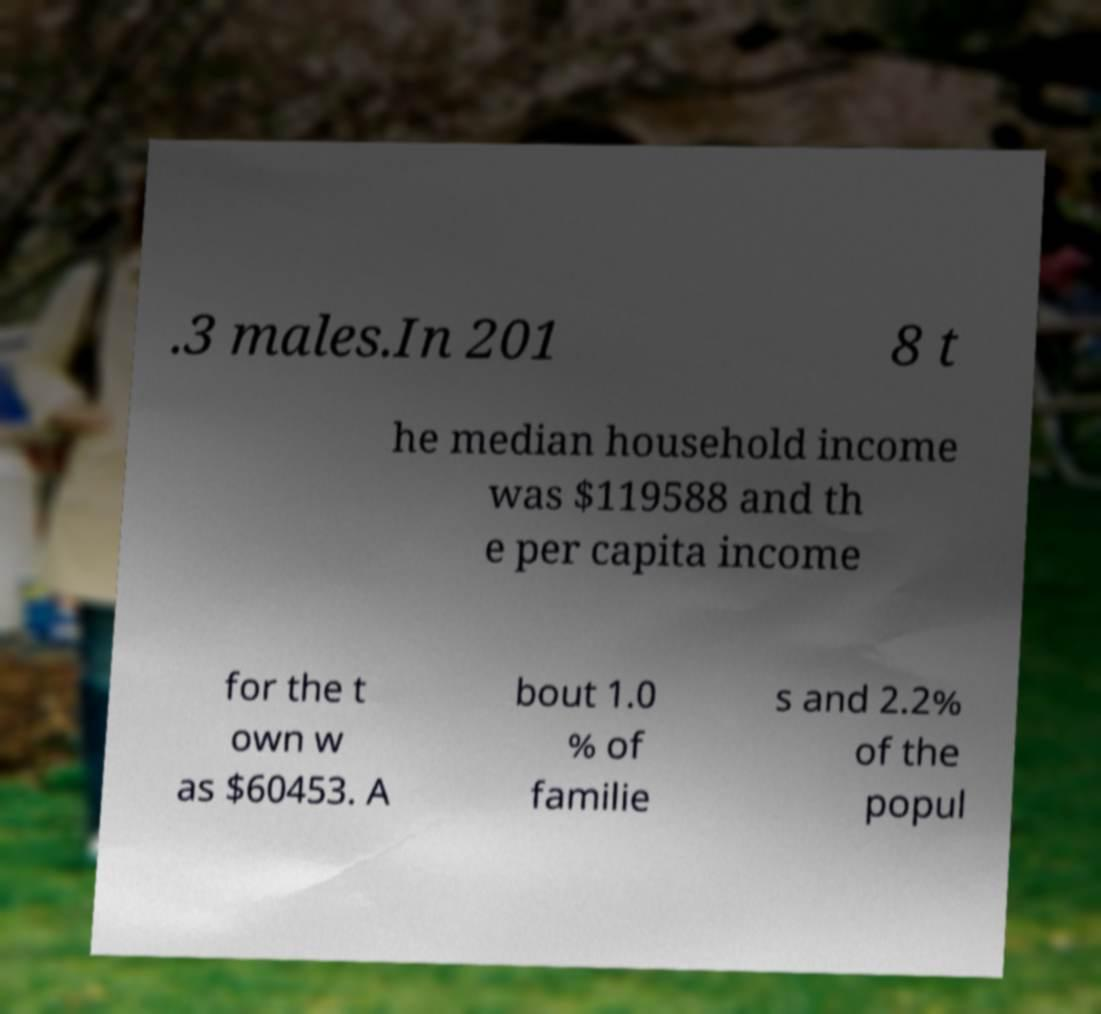Could you assist in decoding the text presented in this image and type it out clearly? .3 males.In 201 8 t he median household income was $119588 and th e per capita income for the t own w as $60453. A bout 1.0 % of familie s and 2.2% of the popul 